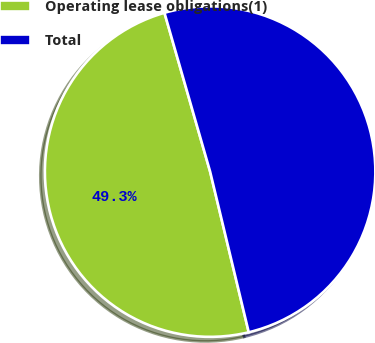Convert chart. <chart><loc_0><loc_0><loc_500><loc_500><pie_chart><fcel>Operating lease obligations(1)<fcel>Total<nl><fcel>49.3%<fcel>50.7%<nl></chart> 